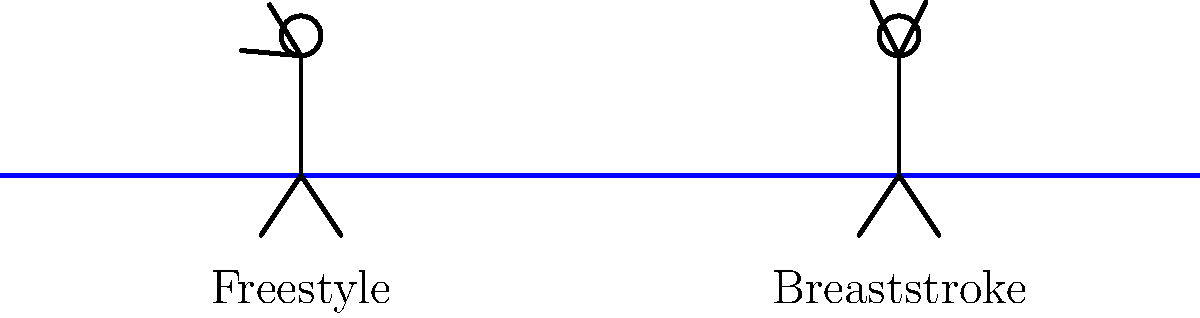As a project manager overseeing the development of a swimming performance analysis system, you need to understand the efficiency of different swimming strokes. Based on the stick figure diagrams showing arm positions for freestyle and breaststroke, which stroke is generally considered more efficient for covering long distances, and why? To determine the efficiency of swimming strokes, we need to consider several factors:

1. Propulsion: The amount of forward motion generated by each stroke.
2. Drag: The resistance encountered by the swimmer's body in the water.
3. Energy expenditure: The amount of effort required to perform each stroke.

Analyzing the diagrams:

1. Freestyle (left figure):
   - Arms move alternately, providing continuous propulsion.
   - Body position is streamlined, reducing drag.
   - Head stays mostly in the water, improving body alignment.

2. Breaststroke (right figure):
   - Arms move simultaneously, creating a glide phase between strokes.
   - Body position is less streamlined due to the up-and-down motion.
   - Head comes out of the water for breathing, increasing drag.

Comparing efficiency:

- Freestyle generates more continuous propulsion due to alternating arm movements.
- Freestyle maintains a more streamlined body position, reducing drag.
- Breaststroke requires more energy to lift the head and upper body out of the water for breathing.
- Freestyle allows for a more efficient breathing technique (side breathing) without disrupting the stroke significantly.

The continuous propulsion, reduced drag, and lower energy expenditure make freestyle more efficient for covering long distances.
Answer: Freestyle, due to continuous propulsion, reduced drag, and lower energy expenditure. 